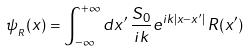Convert formula to latex. <formula><loc_0><loc_0><loc_500><loc_500>\psi _ { _ { R } } ( x ) = \int _ { - \infty } ^ { + \infty } d x ^ { \prime } \, \frac { S _ { 0 } } { i k } e ^ { i k | x - x ^ { \prime } | } \, R ( x ^ { \prime } )</formula> 